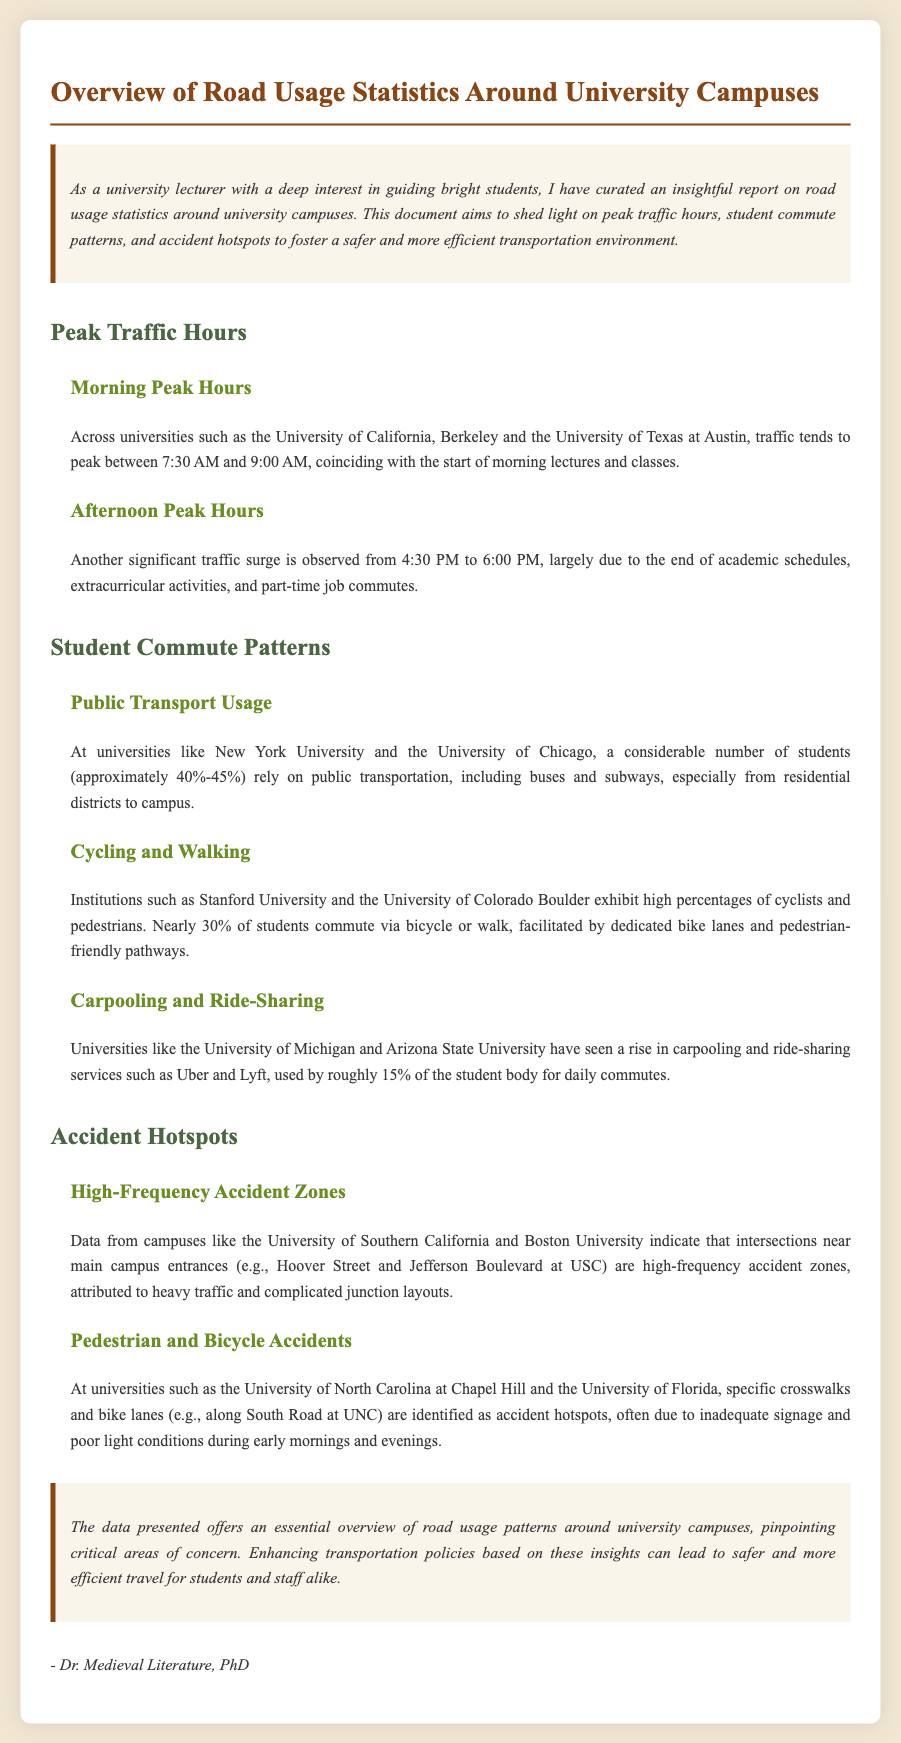What are the morning peak traffic hours? The document states that traffic tends to peak between 7:30 AM and 9:00 AM.
Answer: 7:30 AM and 9:00 AM What is the percentage of students using public transport? The report indicates that approximately 40%-45% of students rely on public transportation.
Answer: 40%-45% Which university has a high frequency of accidents near main campus entrances? The document mentions the University of Southern California as having high-frequency accident zones near main campus entrances.
Answer: University of Southern California What time frame denotes the afternoon peak hours? It is stated that the afternoon peak traffic surge occurs from 4:30 PM to 6:00 PM.
Answer: 4:30 PM to 6:00 PM What percentage of students at Stanford University commute by cycling or walking? The document notes that nearly 30% of students commute via bicycle or walk.
Answer: 30% Which crosswalk is identified as an accident hotspot at UNC? The report specifically mentions South Road at UNC as an identified accident hotspot.
Answer: South Road at UNC What rise in usage is noted for ride-sharing services at the University of Michigan? The document indicates that roughly 15% of the student body uses ride-sharing services for daily commutes.
Answer: 15% Which two universities show significant cycling and walking patterns? The report cites Stanford University and the University of Colorado Boulder for high percentages of cyclists and pedestrians.
Answer: Stanford University and the University of Colorado Boulder What document structure does this report follow? The report includes sections such as Peak Traffic Hours, Student Commute Patterns, and Accident Hotspots.
Answer: Sections like Peak Traffic Hours, Student Commute Patterns, and Accident Hotspots 